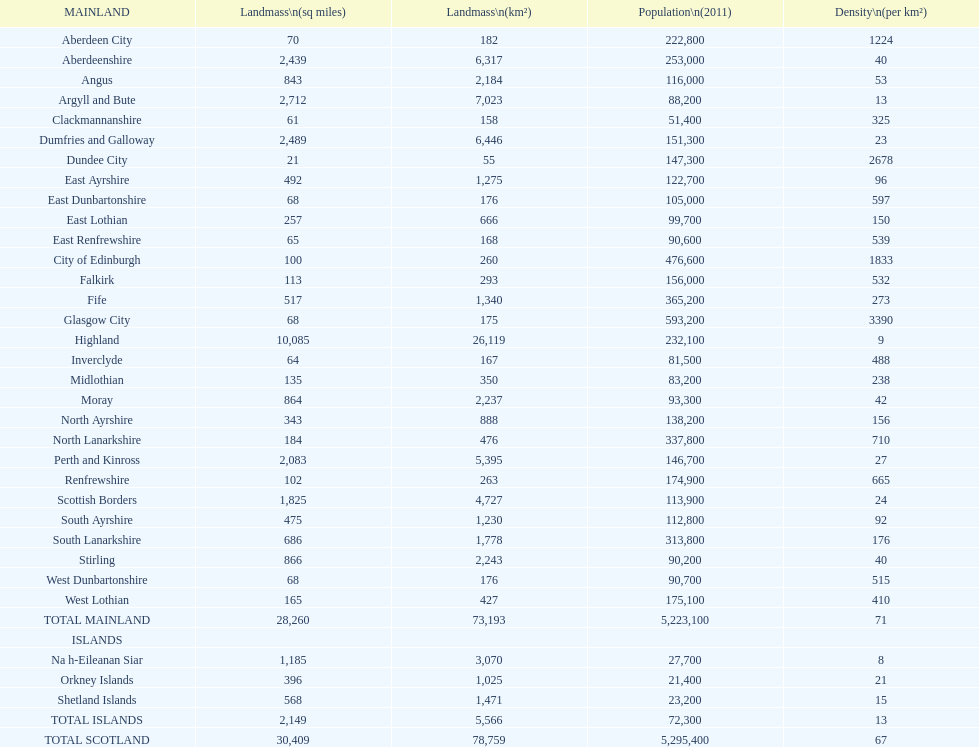What number of mainlands have populations under 100,000? 9. Give me the full table as a dictionary. {'header': ['MAINLAND', 'Landmass\\n(sq miles)', 'Landmass\\n(km²)', 'Population\\n(2011)', 'Density\\n(per km²)'], 'rows': [['Aberdeen City', '70', '182', '222,800', '1224'], ['Aberdeenshire', '2,439', '6,317', '253,000', '40'], ['Angus', '843', '2,184', '116,000', '53'], ['Argyll and Bute', '2,712', '7,023', '88,200', '13'], ['Clackmannanshire', '61', '158', '51,400', '325'], ['Dumfries and Galloway', '2,489', '6,446', '151,300', '23'], ['Dundee City', '21', '55', '147,300', '2678'], ['East Ayrshire', '492', '1,275', '122,700', '96'], ['East Dunbartonshire', '68', '176', '105,000', '597'], ['East Lothian', '257', '666', '99,700', '150'], ['East Renfrewshire', '65', '168', '90,600', '539'], ['City of Edinburgh', '100', '260', '476,600', '1833'], ['Falkirk', '113', '293', '156,000', '532'], ['Fife', '517', '1,340', '365,200', '273'], ['Glasgow City', '68', '175', '593,200', '3390'], ['Highland', '10,085', '26,119', '232,100', '9'], ['Inverclyde', '64', '167', '81,500', '488'], ['Midlothian', '135', '350', '83,200', '238'], ['Moray', '864', '2,237', '93,300', '42'], ['North Ayrshire', '343', '888', '138,200', '156'], ['North Lanarkshire', '184', '476', '337,800', '710'], ['Perth and Kinross', '2,083', '5,395', '146,700', '27'], ['Renfrewshire', '102', '263', '174,900', '665'], ['Scottish Borders', '1,825', '4,727', '113,900', '24'], ['South Ayrshire', '475', '1,230', '112,800', '92'], ['South Lanarkshire', '686', '1,778', '313,800', '176'], ['Stirling', '866', '2,243', '90,200', '40'], ['West Dunbartonshire', '68', '176', '90,700', '515'], ['West Lothian', '165', '427', '175,100', '410'], ['TOTAL MAINLAND', '28,260', '73,193', '5,223,100', '71'], ['ISLANDS', '', '', '', ''], ['Na h-Eileanan Siar', '1,185', '3,070', '27,700', '8'], ['Orkney Islands', '396', '1,025', '21,400', '21'], ['Shetland Islands', '568', '1,471', '23,200', '15'], ['TOTAL ISLANDS', '2,149', '5,566', '72,300', '13'], ['TOTAL SCOTLAND', '30,409', '78,759', '5,295,400', '67']]} 